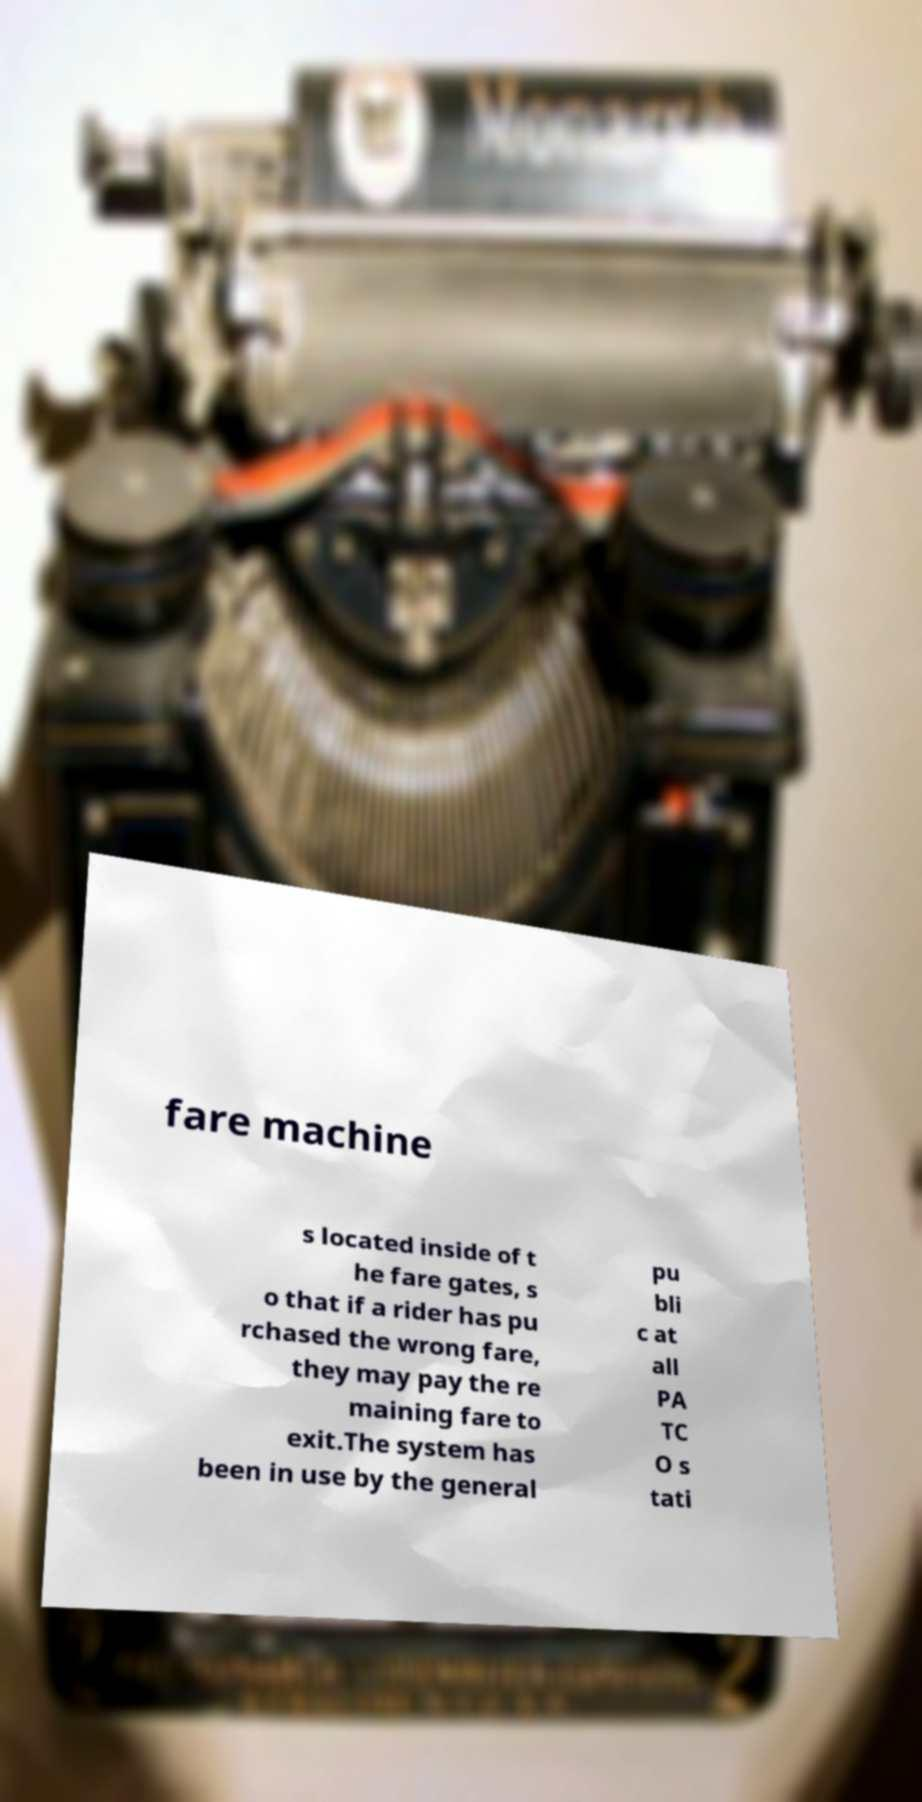Could you assist in decoding the text presented in this image and type it out clearly? fare machine s located inside of t he fare gates, s o that if a rider has pu rchased the wrong fare, they may pay the re maining fare to exit.The system has been in use by the general pu bli c at all PA TC O s tati 